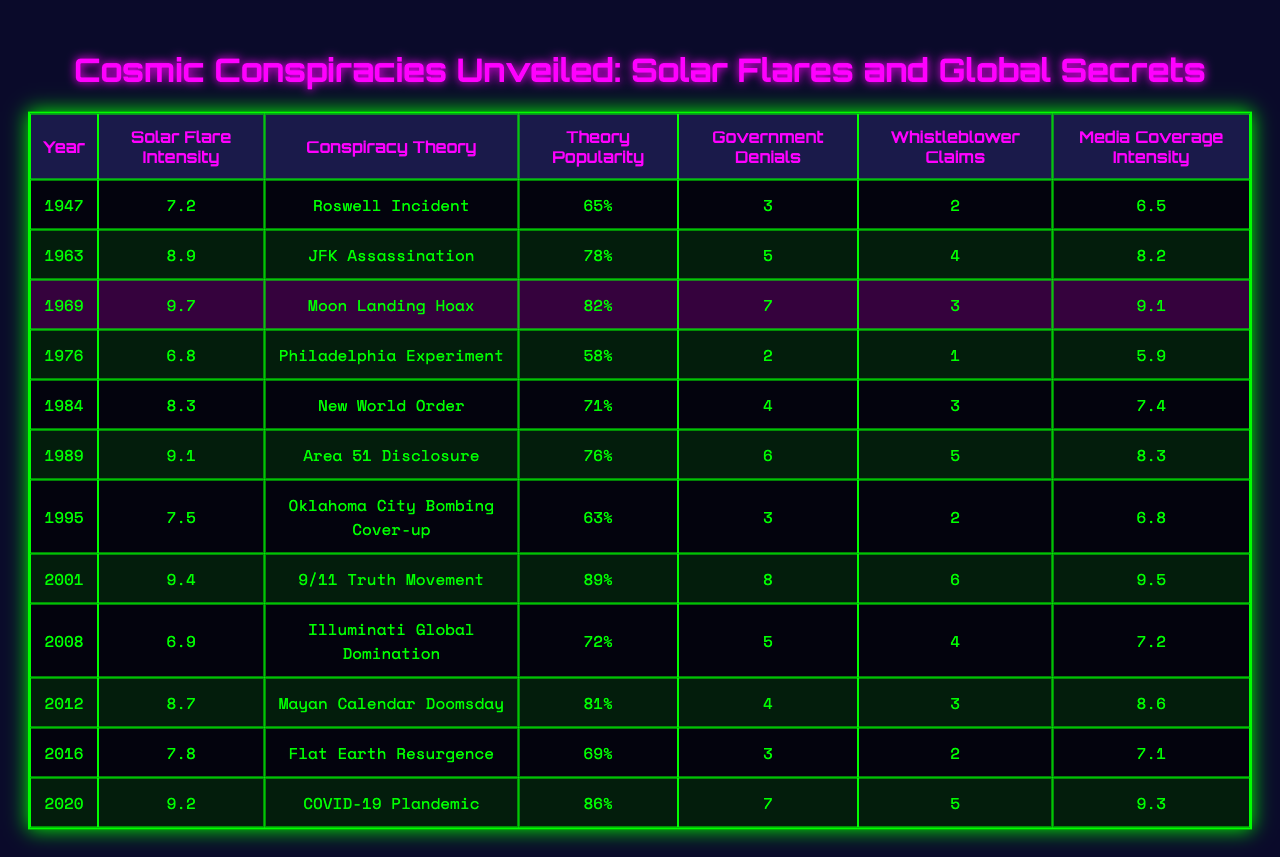What was the conspiracy theory associated with the year 1989? By referring to the table, we can see that the year 1989 corresponds to the conspiracy theory "Area 51 Disclosure."
Answer: Area 51 Disclosure Which year saw the highest solar flare intensity? The table shows that the highest solar flare intensity is 9.7, which occurred in 1969.
Answer: 1969 How many government denials were reported for the "Flat Earth Resurgence" theory? Looking at the table, we find that the "Flat Earth Resurgence" theory, which is from the year 2016, had 3 government denials associated with it.
Answer: 3 What is the average theory popularity for years with solar flare intensity greater than 8.5? The years with solar flare intensity greater than 8.5 are 1963 (78), 1969 (82), 1989 (76), 2001 (89), 2012 (81), and 2020 (86). The average is (78 + 82 + 76 + 89 + 81 + 86) / 6 = 82.67.
Answer: 82.67 Did the intensity of solar flares have a direct correlation with the emergence of the "COVID-19 Plandemic" theory? According to the table, the solar flare intensity in 2020 was 9.2, and the conspiracy theory popularity was quite high at 86%. This suggests a correlation, but further analysis would be needed to confirm any causative relationship.
Answer: Yes, suggests correlation Which conspiracy theory had the least government denials and what year was it reported? By inspecting the table, we can see that the conspiracy theory with the least government denials is "Philadelphia Experiment" from the year 1976, which had only 2 denials.
Answer: Philadelphia Experiment, 1976 Which year had the highest media coverage intensity and what was its value? From the table, we see that the year 2001 had the highest media coverage intensity at 9.5.
Answer: 2001, 9.5 What is the difference in theory popularity between the "New World Order" theory and the "Illuminati Global Domination" theory? The theory popularity for "New World Order" in 1984 is 71%, and for "Illuminati Global Domination" in 2008 is 72%. The difference is 72 - 71 = 1%.
Answer: 1% How many more whistleblower claims were there for the "9/11 Truth Movement" compared to the "Oklahoma City Bombing Cover-up"? The "9/11 Truth Movement" in 2001 had 6 whistleblower claims, while the "Oklahoma City Bombing Cover-up" in 1995 had 2. The difference is 6 - 2 = 4 claims more.
Answer: 4 claims Is there a theory with government denials greater than 6 and a media coverage intensity below 7? Examining the table, we find that the years 2001 and 2020 both have government denials greater than 6 (8 and 7 respectively) but their media coverage intensities are both 9.5 and 9.3. Hence, there is no such theory.
Answer: No Count how many conspiracy theories had a theory popularity of 70% or more? By reviewing the table, we can count the number of theories with popularity percentages of 70% or more: 1963 (78), 1969 (82), 1984 (71), 1989 (76), 2001 (89), 2012 (81), 2020 (86), totaling 7 theories.
Answer: 7 theories 